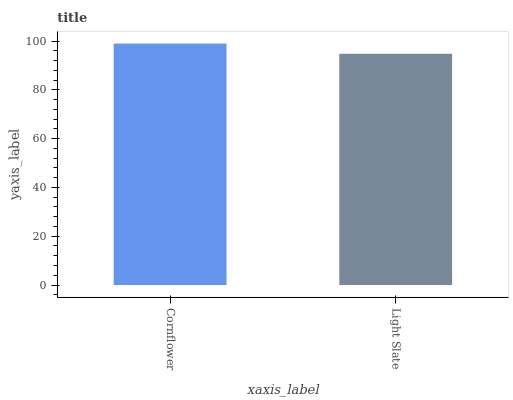Is Light Slate the minimum?
Answer yes or no. Yes. Is Cornflower the maximum?
Answer yes or no. Yes. Is Light Slate the maximum?
Answer yes or no. No. Is Cornflower greater than Light Slate?
Answer yes or no. Yes. Is Light Slate less than Cornflower?
Answer yes or no. Yes. Is Light Slate greater than Cornflower?
Answer yes or no. No. Is Cornflower less than Light Slate?
Answer yes or no. No. Is Cornflower the high median?
Answer yes or no. Yes. Is Light Slate the low median?
Answer yes or no. Yes. Is Light Slate the high median?
Answer yes or no. No. Is Cornflower the low median?
Answer yes or no. No. 